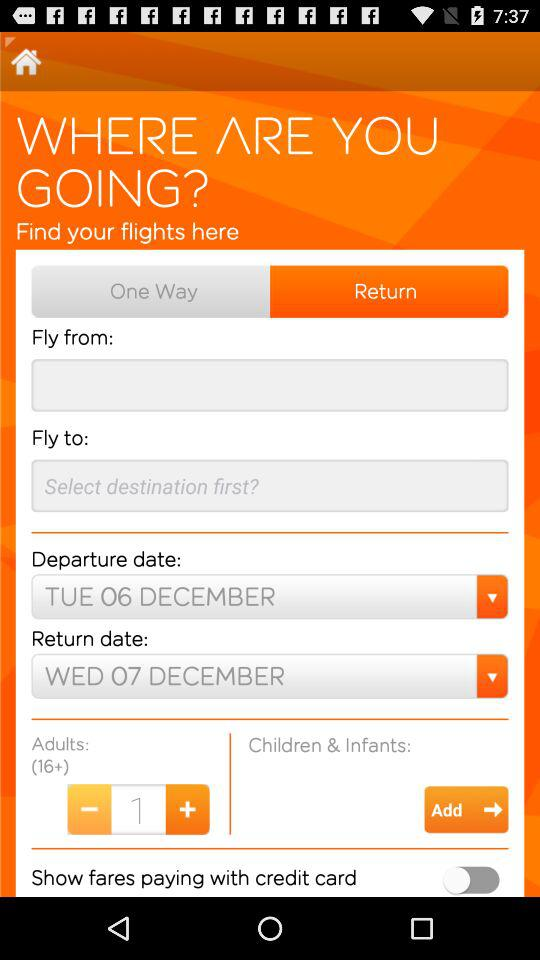How many more days are there between the departure and return dates?
Answer the question using a single word or phrase. 1 